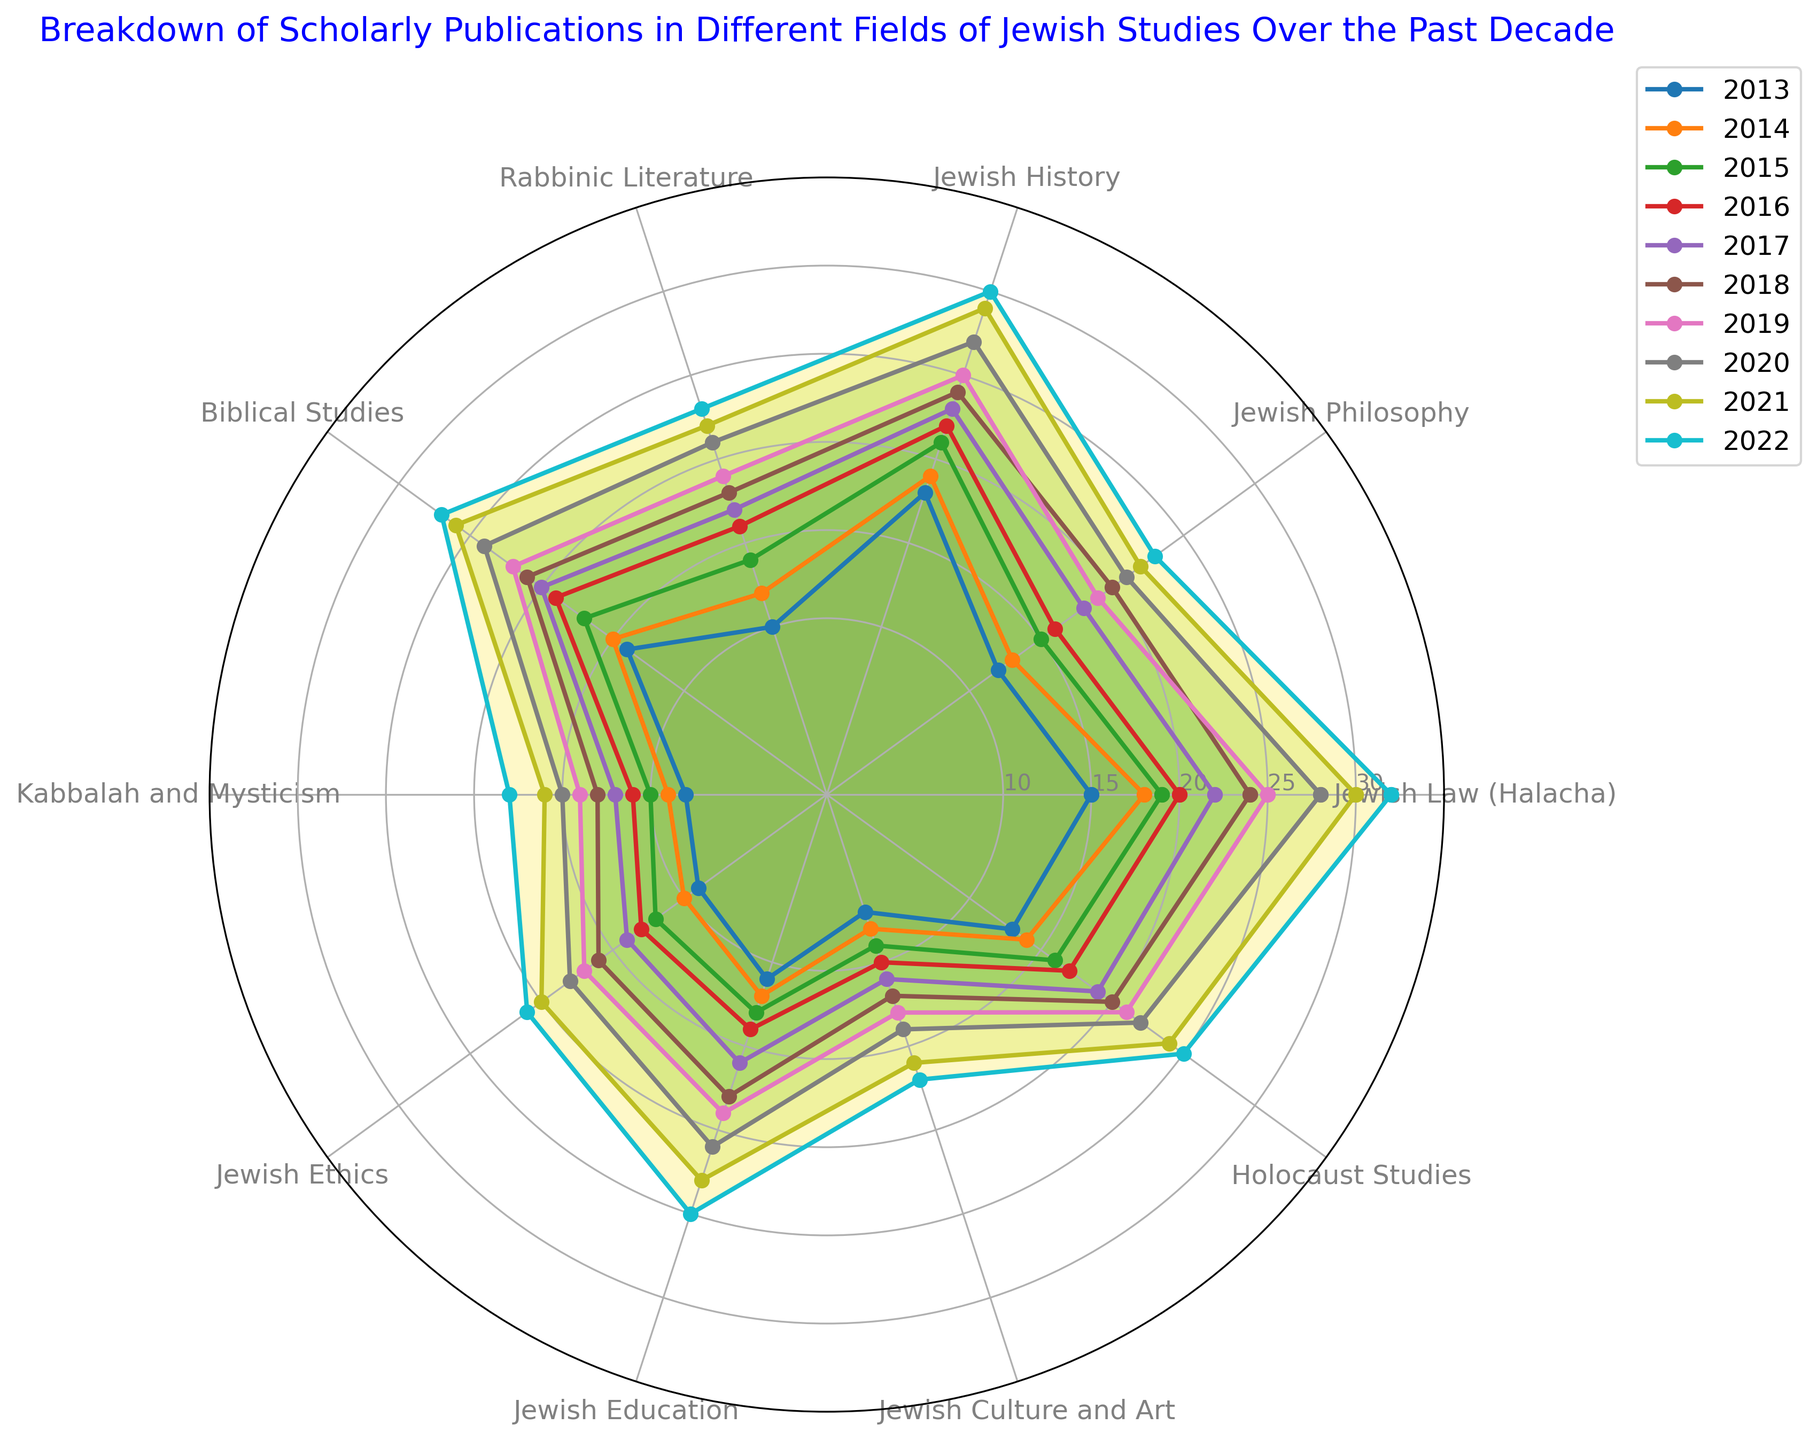Which field has shown the most consistent increase in the number of publications over the past decade? By observing the lines for each field, the field that has the steadiest upward trajectory without significant dips is identified. Jewish Law (Halacha) shows a consistent increase from 2013 to 2022.
Answer: Jewish Law (Halacha) Which field had the lowest number of publications in 2013 and how did its number change by 2022? By looking at the radar chart, the field with the shortest distance from the center in 2013 is Jewish Culture and Art with 7 publications. By 2022, its number of publications increased, showing a longer spoke. From 7 in 2013, it increased to 17 in 2022.
Answer: Jewish Culture and Art, increased from 7 to 17 Compare the number of publications in Jewish Education and Rabbinic Literature in 2022. Which field has more publications? The chart shows the lengths of the spokes for each field in 2022. Jewish Education extends to 25, while Rabbinic Literature extends to 23. Therefore, Jewish Education has more publications in 2022.
Answer: Jewish Education What is the overall trend for Holocaust Studies from 2013 to 2022 based on the radar chart? By examining the line representing Holocaust Studies, we observe that it shows a steady increase in the number of publications each year.
Answer: Steady increase Calculate the average number of publications for Biblical Studies over the past decade. Sum up the number of publications for Biblical Studies from 2013 to 2022 (14 + 15 + 17 + 19 + 20 + 21 + 22 + 24 + 26 + 27 = 205). Divide the total by the number of years (205 / 10).
Answer: 20.5 Which two fields had an equal number of publications in 2020 and what is that number? By going through the chart for the year 2020, identify the lengths of the spokes that intersect at the same point. Jewish Philosophy and Holocaust Studies both have 22 publications in 2020.
Answer: Jewish Philosophy and Holocaust Studies, 22 Identify the field that had the least number of publications in 2015 and describe its trend from 2013 to 2022. The shortest spoke in 2015 corresponds to Kabbalah and Mysticism with 10 publications. From 2013 to 2022, looking at the line for Kabbalah and Mysticism, there is a consistent increase each year.
Answer: Kabbalah and Mysticism, consistent increase Which field experienced the highest absolute increase in the number of publications from 2013 to 2022? Calculate the increase for each field by subtracting the 2013 value from the 2022 value. Jewish Law (Halacha) shows the highest increase: 32 - 15 = 17.
Answer: Jewish Law (Halacha), 17 During which year did the number of publications for Jewish Ethics surpass 15 for the first time? By examining the radar chart, follow the line for Jewish Ethics to see when it first crosses the 15-mark. It surpasses 15 in the year 2018.
Answer: 2018 